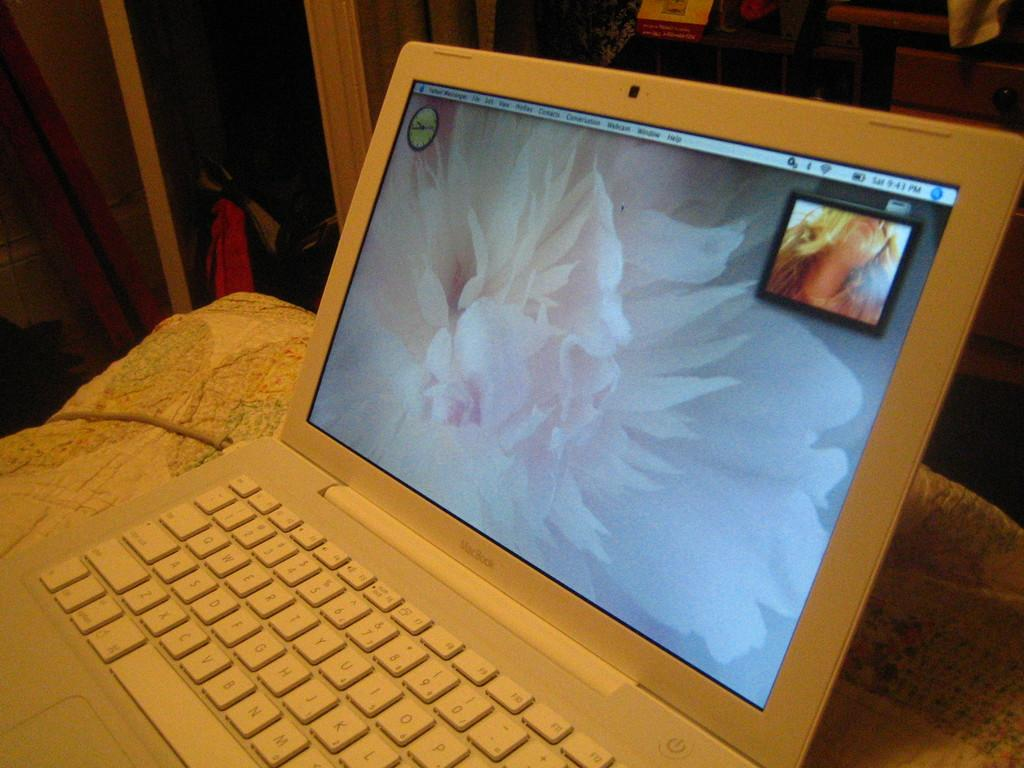What electronic device is visible in the image? There is a laptop in the image. What is connected to the laptop in the image? There is a cable in the image. What type of material is present in the image? There is cloth in the image. What can be seen in the background of the image? There is a wall and other objects in the background of the image. How many geese are flying over the laptop in the image? There are no geese present in the image. What sense is being stimulated by the objects in the image? The provided facts do not mention any specific sense being stimulated by the objects in the image. 